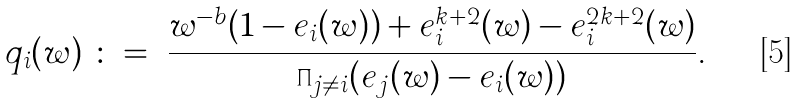Convert formula to latex. <formula><loc_0><loc_0><loc_500><loc_500>q _ { i } ( w ) \ \colon = \ \frac { w ^ { - b } ( 1 - e _ { i } ( w ) ) + e _ { i } ^ { k + 2 } ( w ) - e _ { i } ^ { 2 k + 2 } ( w ) } { \prod _ { j \neq i } ( e _ { j } ( w ) - e _ { i } ( w ) ) } .</formula> 